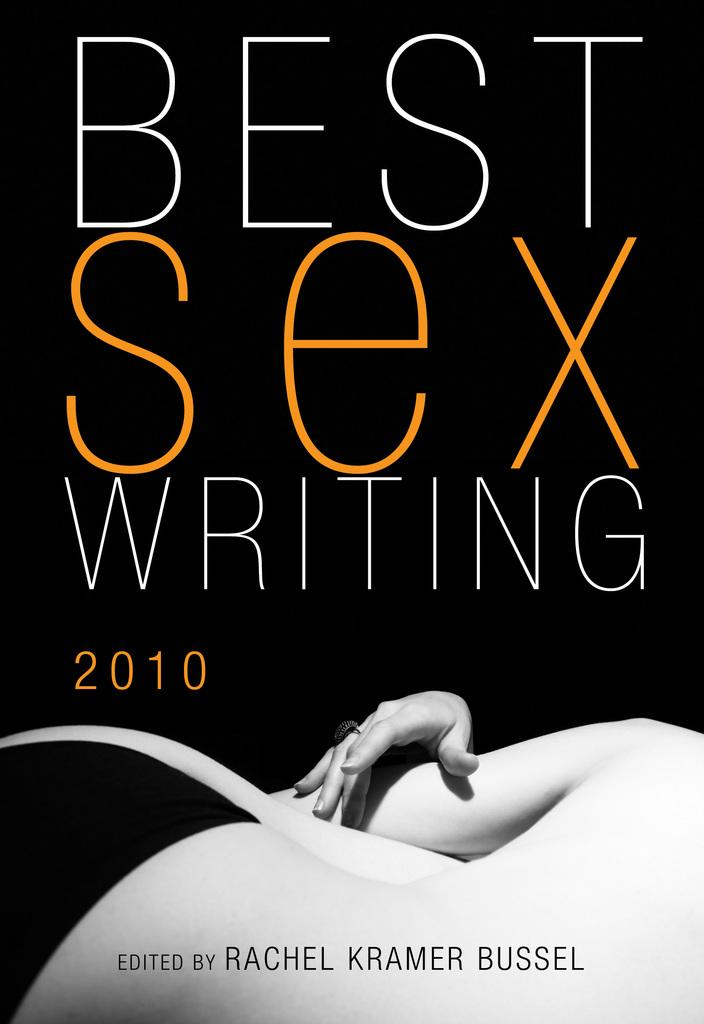What object can be seen in the image? There is a book in the image. What is the title of the book? The book has the name "Best sex writing 2010" on it. What type of plastic is used to make the loaf of oatmeal in the image? There is no loaf of oatmeal or plastic present in the image; it only features a book with a specific title. 